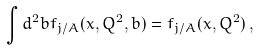Convert formula to latex. <formula><loc_0><loc_0><loc_500><loc_500>\int d ^ { 2 } b f _ { j / A } ( x , Q ^ { 2 } , b ) = f _ { j / A } ( x , Q ^ { 2 } ) \, ,</formula> 